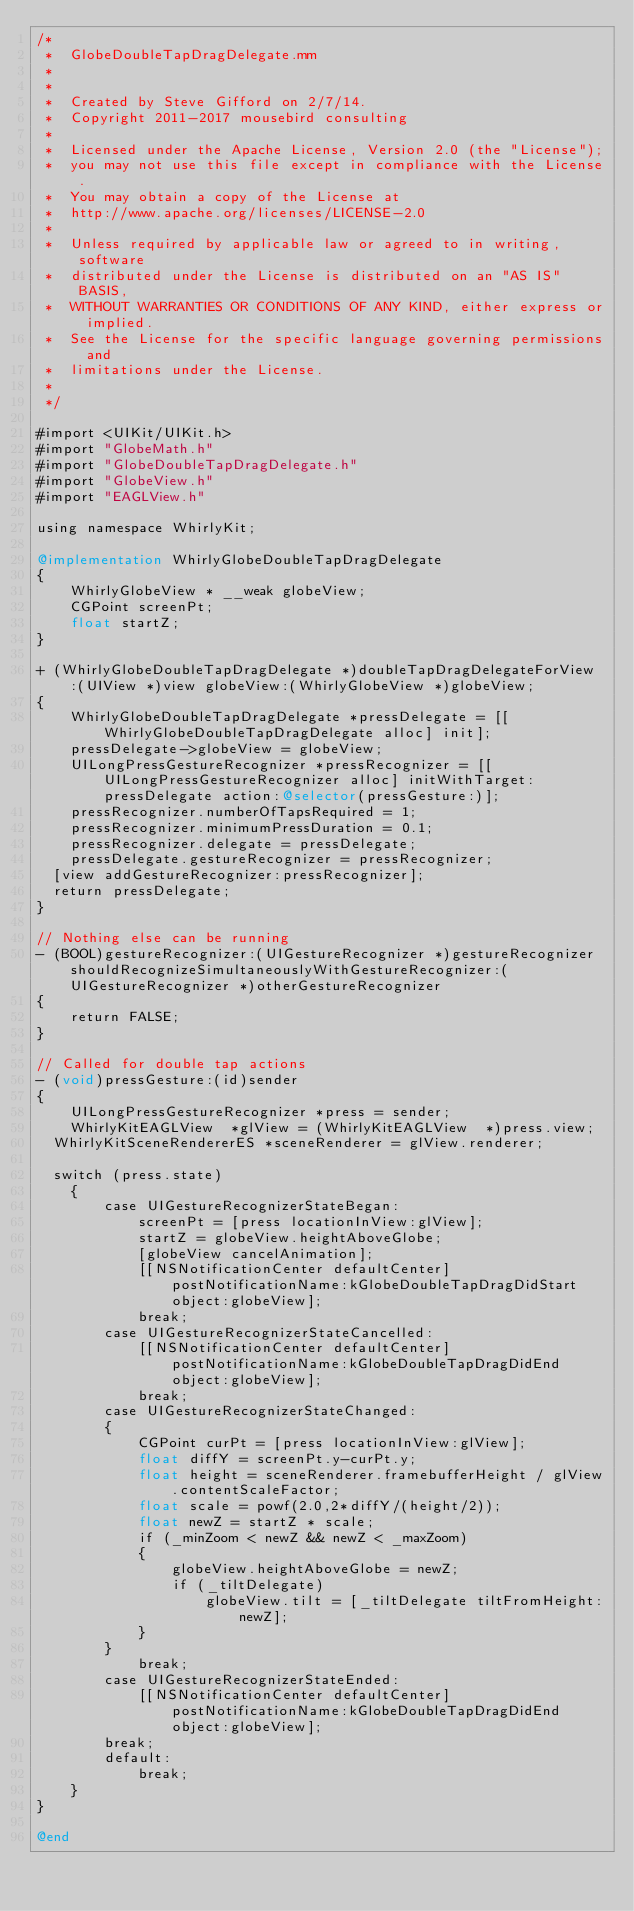Convert code to text. <code><loc_0><loc_0><loc_500><loc_500><_ObjectiveC_>/*
 *  GlobeDoubleTapDragDelegate.mm
 *
 *
 *  Created by Steve Gifford on 2/7/14.
 *  Copyright 2011-2017 mousebird consulting
 *
 *  Licensed under the Apache License, Version 2.0 (the "License");
 *  you may not use this file except in compliance with the License.
 *  You may obtain a copy of the License at
 *  http://www.apache.org/licenses/LICENSE-2.0
 *
 *  Unless required by applicable law or agreed to in writing, software
 *  distributed under the License is distributed on an "AS IS" BASIS,
 *  WITHOUT WARRANTIES OR CONDITIONS OF ANY KIND, either express or implied.
 *  See the License for the specific language governing permissions and
 *  limitations under the License.
 *
 */

#import <UIKit/UIKit.h>
#import "GlobeMath.h"
#import "GlobeDoubleTapDragDelegate.h"
#import "GlobeView.h"
#import "EAGLView.h"

using namespace WhirlyKit;

@implementation WhirlyGlobeDoubleTapDragDelegate
{
    WhirlyGlobeView * __weak globeView;
    CGPoint screenPt;
    float startZ;
}

+ (WhirlyGlobeDoubleTapDragDelegate *)doubleTapDragDelegateForView:(UIView *)view globeView:(WhirlyGlobeView *)globeView;
{
    WhirlyGlobeDoubleTapDragDelegate *pressDelegate = [[WhirlyGlobeDoubleTapDragDelegate alloc] init];
    pressDelegate->globeView = globeView;
    UILongPressGestureRecognizer *pressRecognizer = [[UILongPressGestureRecognizer alloc] initWithTarget:pressDelegate action:@selector(pressGesture:)];
    pressRecognizer.numberOfTapsRequired = 1;
    pressRecognizer.minimumPressDuration = 0.1;
    pressRecognizer.delegate = pressDelegate;
    pressDelegate.gestureRecognizer = pressRecognizer;
	[view addGestureRecognizer:pressRecognizer];
	return pressDelegate;
}

// Nothing else can be running
- (BOOL)gestureRecognizer:(UIGestureRecognizer *)gestureRecognizer shouldRecognizeSimultaneouslyWithGestureRecognizer:(UIGestureRecognizer *)otherGestureRecognizer
{
    return FALSE;
}

// Called for double tap actions
- (void)pressGesture:(id)sender
{
    UILongPressGestureRecognizer *press = sender;
    WhirlyKitEAGLView  *glView = (WhirlyKitEAGLView  *)press.view;
	WhirlyKitSceneRendererES *sceneRenderer = glView.renderer;
    
	switch (press.state)
    {
        case UIGestureRecognizerStateBegan:
            screenPt = [press locationInView:glView];
            startZ = globeView.heightAboveGlobe;
            [globeView cancelAnimation];
            [[NSNotificationCenter defaultCenter] postNotificationName:kGlobeDoubleTapDragDidStart object:globeView];
            break;
        case UIGestureRecognizerStateCancelled:
            [[NSNotificationCenter defaultCenter] postNotificationName:kGlobeDoubleTapDragDidEnd object:globeView];
            break;
        case UIGestureRecognizerStateChanged:
        {
            CGPoint curPt = [press locationInView:glView];
            float diffY = screenPt.y-curPt.y;
            float height = sceneRenderer.framebufferHeight / glView.contentScaleFactor;
            float scale = powf(2.0,2*diffY/(height/2));
            float newZ = startZ * scale;
            if (_minZoom < newZ && newZ < _maxZoom)
            {
                globeView.heightAboveGlobe = newZ;
                if (_tiltDelegate)
                    globeView.tilt = [_tiltDelegate tiltFromHeight:newZ];
            }
        }
            break;
        case UIGestureRecognizerStateEnded:
            [[NSNotificationCenter defaultCenter] postNotificationName:kGlobeDoubleTapDragDidEnd object:globeView];
        break;
        default:
            break;
    }
}

@end
</code> 